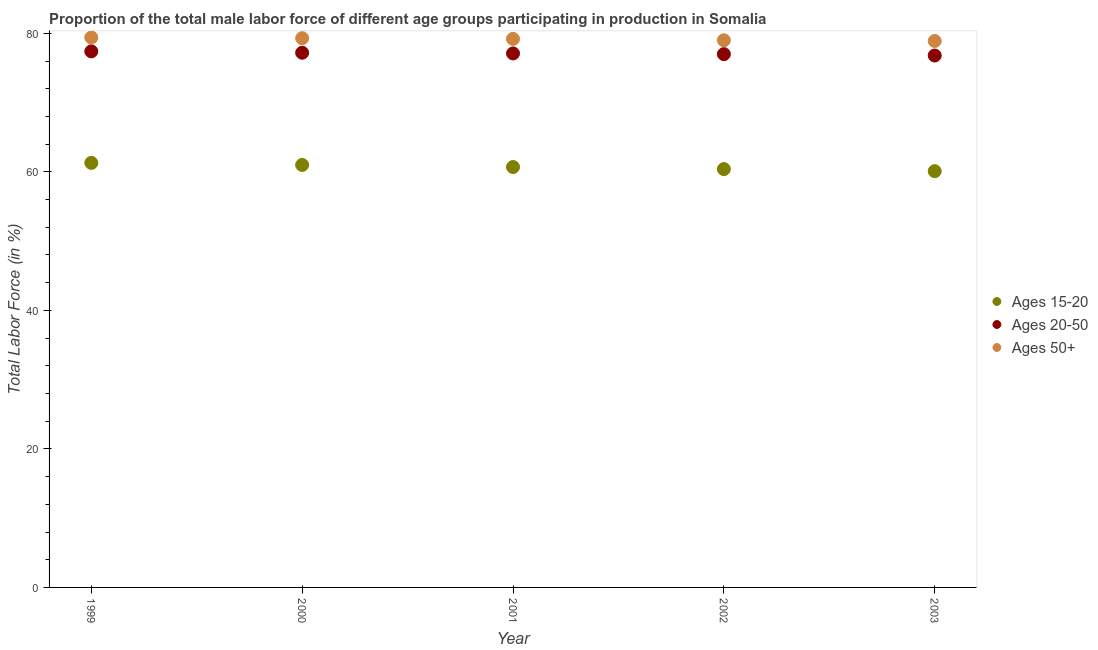What is the percentage of male labor force within the age group 20-50 in 2000?
Your answer should be compact. 77.2. Across all years, what is the maximum percentage of male labor force within the age group 15-20?
Offer a terse response. 61.3. Across all years, what is the minimum percentage of male labor force within the age group 20-50?
Provide a short and direct response. 76.8. In which year was the percentage of male labor force above age 50 maximum?
Make the answer very short. 1999. What is the total percentage of male labor force within the age group 20-50 in the graph?
Offer a very short reply. 385.5. What is the difference between the percentage of male labor force within the age group 15-20 in 1999 and that in 2001?
Your response must be concise. 0.6. What is the difference between the percentage of male labor force within the age group 15-20 in 1999 and the percentage of male labor force above age 50 in 2000?
Make the answer very short. -18. What is the average percentage of male labor force within the age group 15-20 per year?
Offer a very short reply. 60.7. In the year 2001, what is the difference between the percentage of male labor force above age 50 and percentage of male labor force within the age group 20-50?
Give a very brief answer. 2.1. What is the ratio of the percentage of male labor force within the age group 20-50 in 2000 to that in 2003?
Keep it short and to the point. 1.01. Is the percentage of male labor force within the age group 20-50 in 2000 less than that in 2002?
Give a very brief answer. No. What is the difference between the highest and the second highest percentage of male labor force above age 50?
Make the answer very short. 0.1. What is the difference between the highest and the lowest percentage of male labor force within the age group 20-50?
Your answer should be compact. 0.6. Is the sum of the percentage of male labor force within the age group 15-20 in 2002 and 2003 greater than the maximum percentage of male labor force above age 50 across all years?
Your answer should be compact. Yes. Is the percentage of male labor force above age 50 strictly greater than the percentage of male labor force within the age group 20-50 over the years?
Provide a succinct answer. Yes. What is the difference between two consecutive major ticks on the Y-axis?
Your answer should be very brief. 20. Does the graph contain any zero values?
Keep it short and to the point. No. How many legend labels are there?
Your answer should be compact. 3. How are the legend labels stacked?
Offer a very short reply. Vertical. What is the title of the graph?
Your response must be concise. Proportion of the total male labor force of different age groups participating in production in Somalia. What is the label or title of the X-axis?
Give a very brief answer. Year. What is the Total Labor Force (in %) in Ages 15-20 in 1999?
Your response must be concise. 61.3. What is the Total Labor Force (in %) of Ages 20-50 in 1999?
Your response must be concise. 77.4. What is the Total Labor Force (in %) of Ages 50+ in 1999?
Ensure brevity in your answer.  79.4. What is the Total Labor Force (in %) of Ages 15-20 in 2000?
Provide a short and direct response. 61. What is the Total Labor Force (in %) of Ages 20-50 in 2000?
Your answer should be very brief. 77.2. What is the Total Labor Force (in %) of Ages 50+ in 2000?
Make the answer very short. 79.3. What is the Total Labor Force (in %) in Ages 15-20 in 2001?
Offer a very short reply. 60.7. What is the Total Labor Force (in %) in Ages 20-50 in 2001?
Offer a terse response. 77.1. What is the Total Labor Force (in %) in Ages 50+ in 2001?
Offer a terse response. 79.2. What is the Total Labor Force (in %) in Ages 15-20 in 2002?
Provide a succinct answer. 60.4. What is the Total Labor Force (in %) in Ages 20-50 in 2002?
Offer a very short reply. 77. What is the Total Labor Force (in %) in Ages 50+ in 2002?
Make the answer very short. 79. What is the Total Labor Force (in %) in Ages 15-20 in 2003?
Give a very brief answer. 60.1. What is the Total Labor Force (in %) in Ages 20-50 in 2003?
Give a very brief answer. 76.8. What is the Total Labor Force (in %) of Ages 50+ in 2003?
Ensure brevity in your answer.  78.9. Across all years, what is the maximum Total Labor Force (in %) of Ages 15-20?
Give a very brief answer. 61.3. Across all years, what is the maximum Total Labor Force (in %) in Ages 20-50?
Offer a very short reply. 77.4. Across all years, what is the maximum Total Labor Force (in %) of Ages 50+?
Ensure brevity in your answer.  79.4. Across all years, what is the minimum Total Labor Force (in %) of Ages 15-20?
Give a very brief answer. 60.1. Across all years, what is the minimum Total Labor Force (in %) in Ages 20-50?
Provide a short and direct response. 76.8. Across all years, what is the minimum Total Labor Force (in %) in Ages 50+?
Provide a short and direct response. 78.9. What is the total Total Labor Force (in %) in Ages 15-20 in the graph?
Provide a short and direct response. 303.5. What is the total Total Labor Force (in %) in Ages 20-50 in the graph?
Provide a succinct answer. 385.5. What is the total Total Labor Force (in %) of Ages 50+ in the graph?
Provide a succinct answer. 395.8. What is the difference between the Total Labor Force (in %) of Ages 20-50 in 1999 and that in 2000?
Provide a succinct answer. 0.2. What is the difference between the Total Labor Force (in %) in Ages 50+ in 1999 and that in 2000?
Offer a terse response. 0.1. What is the difference between the Total Labor Force (in %) of Ages 20-50 in 1999 and that in 2001?
Ensure brevity in your answer.  0.3. What is the difference between the Total Labor Force (in %) of Ages 20-50 in 1999 and that in 2002?
Offer a terse response. 0.4. What is the difference between the Total Labor Force (in %) in Ages 50+ in 1999 and that in 2002?
Your answer should be very brief. 0.4. What is the difference between the Total Labor Force (in %) in Ages 20-50 in 1999 and that in 2003?
Your answer should be very brief. 0.6. What is the difference between the Total Labor Force (in %) in Ages 50+ in 1999 and that in 2003?
Offer a terse response. 0.5. What is the difference between the Total Labor Force (in %) of Ages 20-50 in 2000 and that in 2001?
Make the answer very short. 0.1. What is the difference between the Total Labor Force (in %) in Ages 50+ in 2000 and that in 2001?
Offer a terse response. 0.1. What is the difference between the Total Labor Force (in %) of Ages 15-20 in 2000 and that in 2002?
Offer a terse response. 0.6. What is the difference between the Total Labor Force (in %) of Ages 20-50 in 2000 and that in 2002?
Make the answer very short. 0.2. What is the difference between the Total Labor Force (in %) of Ages 20-50 in 2000 and that in 2003?
Your answer should be compact. 0.4. What is the difference between the Total Labor Force (in %) in Ages 50+ in 2000 and that in 2003?
Your answer should be very brief. 0.4. What is the difference between the Total Labor Force (in %) in Ages 50+ in 2001 and that in 2002?
Keep it short and to the point. 0.2. What is the difference between the Total Labor Force (in %) of Ages 20-50 in 2001 and that in 2003?
Provide a succinct answer. 0.3. What is the difference between the Total Labor Force (in %) in Ages 20-50 in 2002 and that in 2003?
Ensure brevity in your answer.  0.2. What is the difference between the Total Labor Force (in %) of Ages 50+ in 2002 and that in 2003?
Your response must be concise. 0.1. What is the difference between the Total Labor Force (in %) in Ages 15-20 in 1999 and the Total Labor Force (in %) in Ages 20-50 in 2000?
Ensure brevity in your answer.  -15.9. What is the difference between the Total Labor Force (in %) of Ages 15-20 in 1999 and the Total Labor Force (in %) of Ages 20-50 in 2001?
Offer a very short reply. -15.8. What is the difference between the Total Labor Force (in %) of Ages 15-20 in 1999 and the Total Labor Force (in %) of Ages 50+ in 2001?
Provide a short and direct response. -17.9. What is the difference between the Total Labor Force (in %) in Ages 15-20 in 1999 and the Total Labor Force (in %) in Ages 20-50 in 2002?
Keep it short and to the point. -15.7. What is the difference between the Total Labor Force (in %) in Ages 15-20 in 1999 and the Total Labor Force (in %) in Ages 50+ in 2002?
Your response must be concise. -17.7. What is the difference between the Total Labor Force (in %) in Ages 20-50 in 1999 and the Total Labor Force (in %) in Ages 50+ in 2002?
Provide a succinct answer. -1.6. What is the difference between the Total Labor Force (in %) of Ages 15-20 in 1999 and the Total Labor Force (in %) of Ages 20-50 in 2003?
Your answer should be compact. -15.5. What is the difference between the Total Labor Force (in %) of Ages 15-20 in 1999 and the Total Labor Force (in %) of Ages 50+ in 2003?
Ensure brevity in your answer.  -17.6. What is the difference between the Total Labor Force (in %) in Ages 15-20 in 2000 and the Total Labor Force (in %) in Ages 20-50 in 2001?
Provide a short and direct response. -16.1. What is the difference between the Total Labor Force (in %) of Ages 15-20 in 2000 and the Total Labor Force (in %) of Ages 50+ in 2001?
Offer a terse response. -18.2. What is the difference between the Total Labor Force (in %) of Ages 20-50 in 2000 and the Total Labor Force (in %) of Ages 50+ in 2002?
Your response must be concise. -1.8. What is the difference between the Total Labor Force (in %) of Ages 15-20 in 2000 and the Total Labor Force (in %) of Ages 20-50 in 2003?
Your answer should be compact. -15.8. What is the difference between the Total Labor Force (in %) in Ages 15-20 in 2000 and the Total Labor Force (in %) in Ages 50+ in 2003?
Offer a very short reply. -17.9. What is the difference between the Total Labor Force (in %) in Ages 20-50 in 2000 and the Total Labor Force (in %) in Ages 50+ in 2003?
Provide a short and direct response. -1.7. What is the difference between the Total Labor Force (in %) of Ages 15-20 in 2001 and the Total Labor Force (in %) of Ages 20-50 in 2002?
Keep it short and to the point. -16.3. What is the difference between the Total Labor Force (in %) in Ages 15-20 in 2001 and the Total Labor Force (in %) in Ages 50+ in 2002?
Offer a terse response. -18.3. What is the difference between the Total Labor Force (in %) in Ages 15-20 in 2001 and the Total Labor Force (in %) in Ages 20-50 in 2003?
Offer a very short reply. -16.1. What is the difference between the Total Labor Force (in %) of Ages 15-20 in 2001 and the Total Labor Force (in %) of Ages 50+ in 2003?
Offer a terse response. -18.2. What is the difference between the Total Labor Force (in %) of Ages 20-50 in 2001 and the Total Labor Force (in %) of Ages 50+ in 2003?
Ensure brevity in your answer.  -1.8. What is the difference between the Total Labor Force (in %) in Ages 15-20 in 2002 and the Total Labor Force (in %) in Ages 20-50 in 2003?
Your response must be concise. -16.4. What is the difference between the Total Labor Force (in %) of Ages 15-20 in 2002 and the Total Labor Force (in %) of Ages 50+ in 2003?
Your response must be concise. -18.5. What is the average Total Labor Force (in %) of Ages 15-20 per year?
Your answer should be compact. 60.7. What is the average Total Labor Force (in %) in Ages 20-50 per year?
Ensure brevity in your answer.  77.1. What is the average Total Labor Force (in %) in Ages 50+ per year?
Offer a terse response. 79.16. In the year 1999, what is the difference between the Total Labor Force (in %) in Ages 15-20 and Total Labor Force (in %) in Ages 20-50?
Offer a very short reply. -16.1. In the year 1999, what is the difference between the Total Labor Force (in %) of Ages 15-20 and Total Labor Force (in %) of Ages 50+?
Offer a very short reply. -18.1. In the year 2000, what is the difference between the Total Labor Force (in %) in Ages 15-20 and Total Labor Force (in %) in Ages 20-50?
Your answer should be very brief. -16.2. In the year 2000, what is the difference between the Total Labor Force (in %) in Ages 15-20 and Total Labor Force (in %) in Ages 50+?
Ensure brevity in your answer.  -18.3. In the year 2001, what is the difference between the Total Labor Force (in %) of Ages 15-20 and Total Labor Force (in %) of Ages 20-50?
Offer a terse response. -16.4. In the year 2001, what is the difference between the Total Labor Force (in %) of Ages 15-20 and Total Labor Force (in %) of Ages 50+?
Your answer should be compact. -18.5. In the year 2001, what is the difference between the Total Labor Force (in %) of Ages 20-50 and Total Labor Force (in %) of Ages 50+?
Your response must be concise. -2.1. In the year 2002, what is the difference between the Total Labor Force (in %) in Ages 15-20 and Total Labor Force (in %) in Ages 20-50?
Provide a short and direct response. -16.6. In the year 2002, what is the difference between the Total Labor Force (in %) of Ages 15-20 and Total Labor Force (in %) of Ages 50+?
Provide a succinct answer. -18.6. In the year 2003, what is the difference between the Total Labor Force (in %) of Ages 15-20 and Total Labor Force (in %) of Ages 20-50?
Keep it short and to the point. -16.7. In the year 2003, what is the difference between the Total Labor Force (in %) of Ages 15-20 and Total Labor Force (in %) of Ages 50+?
Offer a very short reply. -18.8. What is the ratio of the Total Labor Force (in %) of Ages 15-20 in 1999 to that in 2000?
Make the answer very short. 1. What is the ratio of the Total Labor Force (in %) in Ages 20-50 in 1999 to that in 2000?
Keep it short and to the point. 1. What is the ratio of the Total Labor Force (in %) in Ages 15-20 in 1999 to that in 2001?
Provide a short and direct response. 1.01. What is the ratio of the Total Labor Force (in %) in Ages 50+ in 1999 to that in 2001?
Ensure brevity in your answer.  1. What is the ratio of the Total Labor Force (in %) of Ages 15-20 in 1999 to that in 2002?
Your response must be concise. 1.01. What is the ratio of the Total Labor Force (in %) in Ages 20-50 in 1999 to that in 2003?
Provide a short and direct response. 1.01. What is the ratio of the Total Labor Force (in %) of Ages 50+ in 2000 to that in 2001?
Your response must be concise. 1. What is the ratio of the Total Labor Force (in %) of Ages 15-20 in 2000 to that in 2002?
Ensure brevity in your answer.  1.01. What is the ratio of the Total Labor Force (in %) of Ages 20-50 in 2000 to that in 2002?
Provide a short and direct response. 1. What is the ratio of the Total Labor Force (in %) in Ages 50+ in 2000 to that in 2003?
Your answer should be compact. 1.01. What is the ratio of the Total Labor Force (in %) of Ages 15-20 in 2001 to that in 2002?
Your response must be concise. 1. What is the ratio of the Total Labor Force (in %) of Ages 15-20 in 2002 to that in 2003?
Your answer should be compact. 1. What is the ratio of the Total Labor Force (in %) of Ages 20-50 in 2002 to that in 2003?
Your response must be concise. 1. What is the difference between the highest and the second highest Total Labor Force (in %) in Ages 15-20?
Give a very brief answer. 0.3. What is the difference between the highest and the second highest Total Labor Force (in %) in Ages 20-50?
Provide a short and direct response. 0.2. What is the difference between the highest and the second highest Total Labor Force (in %) of Ages 50+?
Your response must be concise. 0.1. 